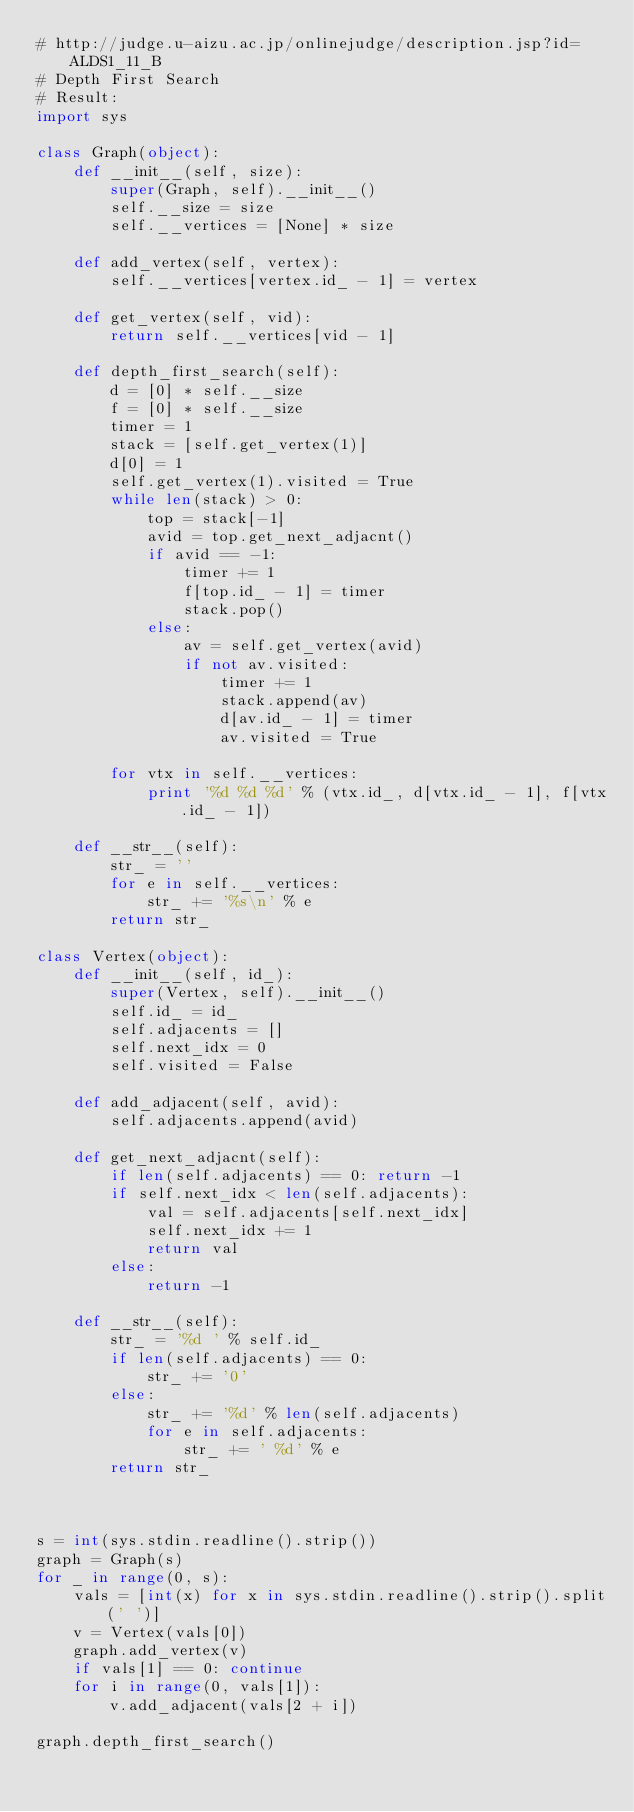Convert code to text. <code><loc_0><loc_0><loc_500><loc_500><_Python_># http://judge.u-aizu.ac.jp/onlinejudge/description.jsp?id=ALDS1_11_B
# Depth First Search
# Result:
import sys

class Graph(object):
    def __init__(self, size):
        super(Graph, self).__init__()
        self.__size = size
        self.__vertices = [None] * size

    def add_vertex(self, vertex):
        self.__vertices[vertex.id_ - 1] = vertex

    def get_vertex(self, vid):
        return self.__vertices[vid - 1]

    def depth_first_search(self):
        d = [0] * self.__size
        f = [0] * self.__size
        timer = 1
        stack = [self.get_vertex(1)]
        d[0] = 1
        self.get_vertex(1).visited = True
        while len(stack) > 0:
            top = stack[-1]
            avid = top.get_next_adjacnt()
            if avid == -1:
                timer += 1
                f[top.id_ - 1] = timer
                stack.pop()
            else:
                av = self.get_vertex(avid)
                if not av.visited:
                    timer += 1
                    stack.append(av)
                    d[av.id_ - 1] = timer
                    av.visited = True

        for vtx in self.__vertices:
            print '%d %d %d' % (vtx.id_, d[vtx.id_ - 1], f[vtx.id_ - 1])

    def __str__(self):
        str_ = ''
        for e in self.__vertices:
            str_ += '%s\n' % e
        return str_

class Vertex(object):
    def __init__(self, id_):
        super(Vertex, self).__init__()
        self.id_ = id_
        self.adjacents = []
        self.next_idx = 0
        self.visited = False

    def add_adjacent(self, avid):
        self.adjacents.append(avid)

    def get_next_adjacnt(self):
        if len(self.adjacents) == 0: return -1
        if self.next_idx < len(self.adjacents):
            val = self.adjacents[self.next_idx]
            self.next_idx += 1
            return val
        else:
            return -1

    def __str__(self):
        str_ = '%d ' % self.id_
        if len(self.adjacents) == 0:
            str_ += '0'
        else:
            str_ += '%d' % len(self.adjacents)
            for e in self.adjacents:
                str_ += ' %d' % e
        return str_



s = int(sys.stdin.readline().strip())
graph = Graph(s)
for _ in range(0, s):
    vals = [int(x) for x in sys.stdin.readline().strip().split(' ')]
    v = Vertex(vals[0])
    graph.add_vertex(v)
    if vals[1] == 0: continue
    for i in range(0, vals[1]):
        v.add_adjacent(vals[2 + i])

graph.depth_first_search()</code> 